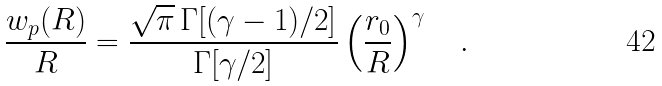<formula> <loc_0><loc_0><loc_500><loc_500>\frac { w _ { p } ( R ) } { R } = \frac { \sqrt { \pi } \, \Gamma [ ( \gamma - 1 ) / 2 ] } { \Gamma [ \gamma / 2 ] } \left ( \frac { r _ { 0 } } { R } \right ) ^ { \gamma } \quad .</formula> 